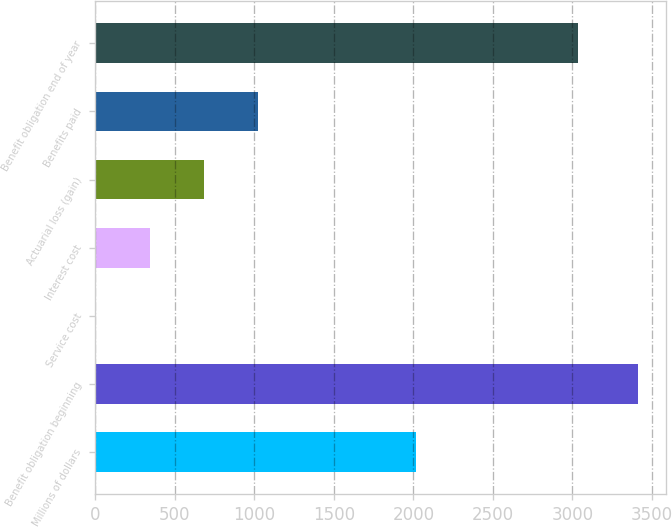<chart> <loc_0><loc_0><loc_500><loc_500><bar_chart><fcel>Millions of dollars<fcel>Benefit obligation beginning<fcel>Service cost<fcel>Interest cost<fcel>Actuarial loss (gain)<fcel>Benefits paid<fcel>Benefit obligation end of year<nl><fcel>2018<fcel>3415<fcel>2<fcel>343.3<fcel>684.6<fcel>1025.9<fcel>3033<nl></chart> 